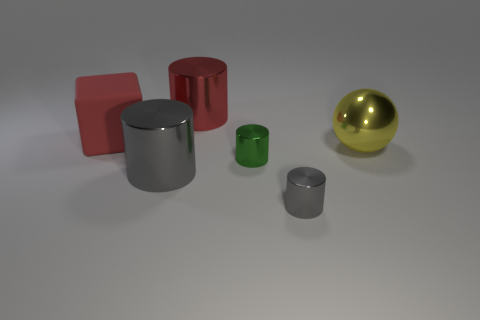Imagine these objects are part of a children's toy set. Can you come up with a story involving them? Absolutely! In a vibrant land called Chromatica, these objects are magical buildings. The tall silver cylinder is a wizard's tower where spells are cast to keep the realm's colors bright. The red block is a cozy inn where travelers rest, and the smaller cylinders are shops that sell rainbow-hued potions. The golden sphere is a precious orb, keeping balance and harmony in Chromatica, with its glow guiding the inhabitants during their nocturnal festivities. 